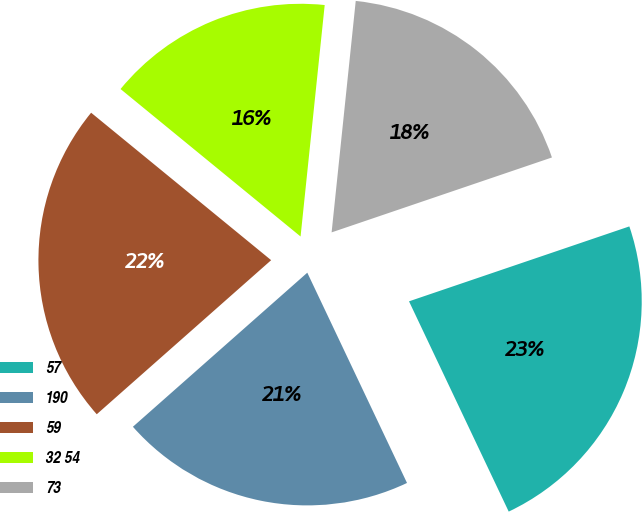<chart> <loc_0><loc_0><loc_500><loc_500><pie_chart><fcel>57<fcel>190<fcel>59<fcel>32 54<fcel>73<nl><fcel>23.17%<fcel>20.53%<fcel>22.44%<fcel>15.73%<fcel>18.13%<nl></chart> 